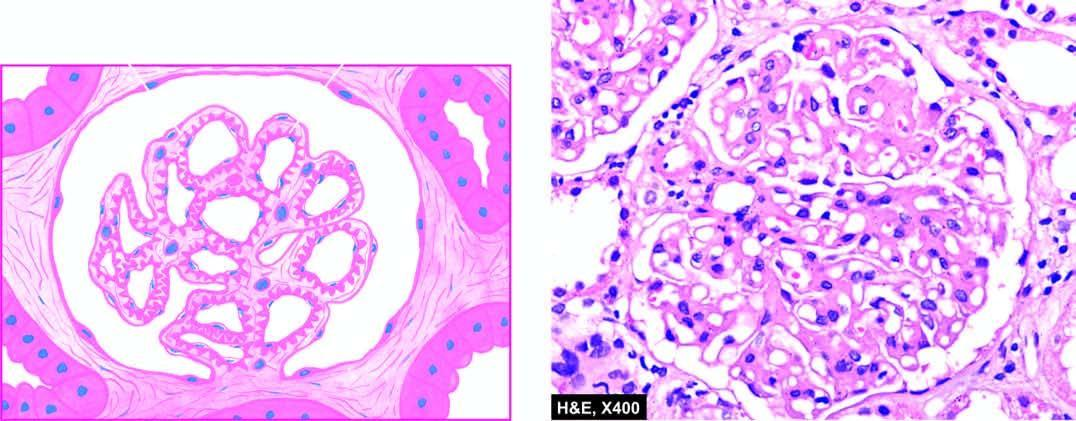re glomeruli normocellular?
Answer the question using a single word or phrase. Yes 